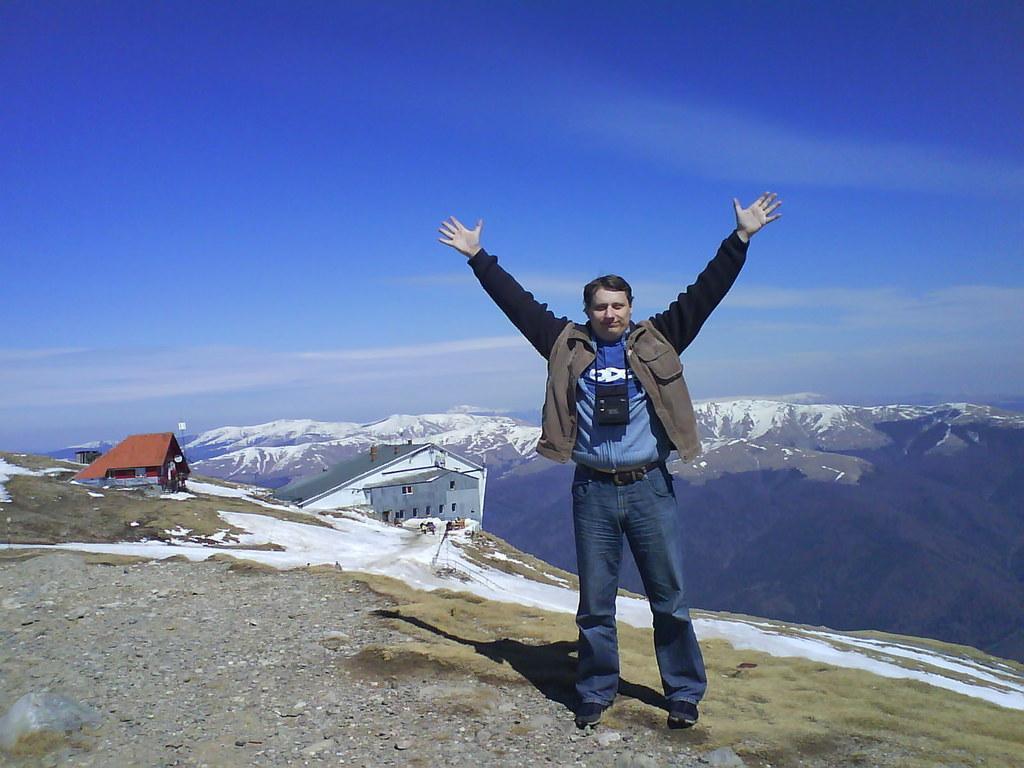Please provide a concise description of this image. In this image I can see a person standing with open hands at a hill station. I can see buildings and at the top of the image I can see the sky.  